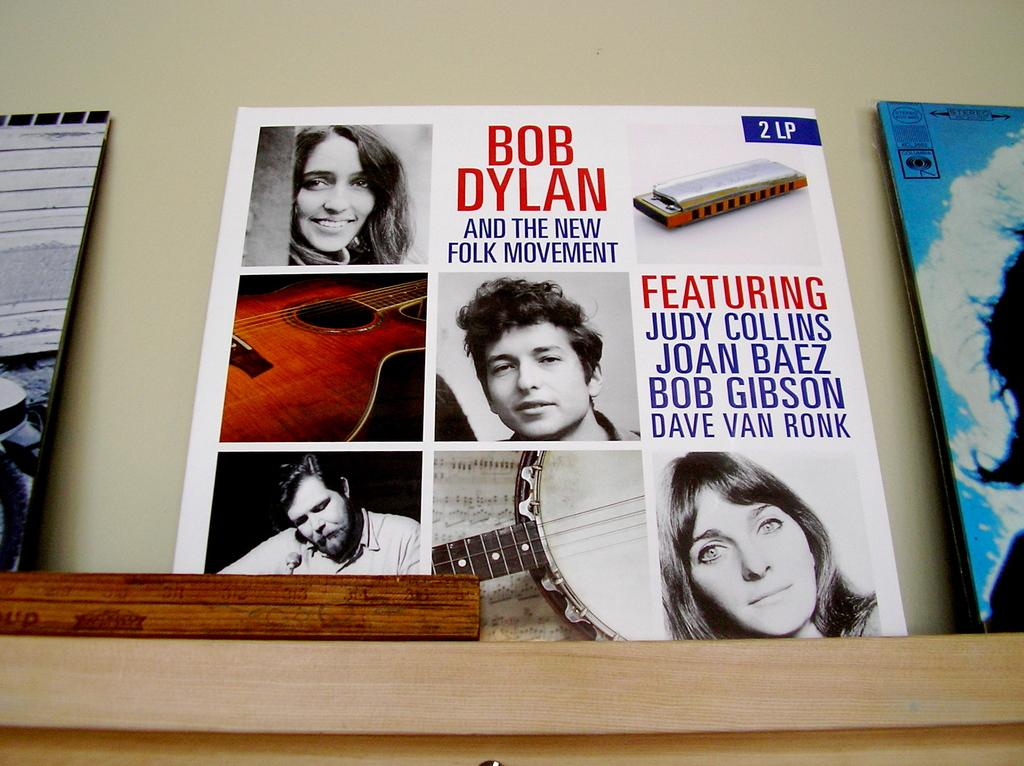<image>
Present a compact description of the photo's key features. A folk record album including music from Bob Dylan and Judy Collins. 